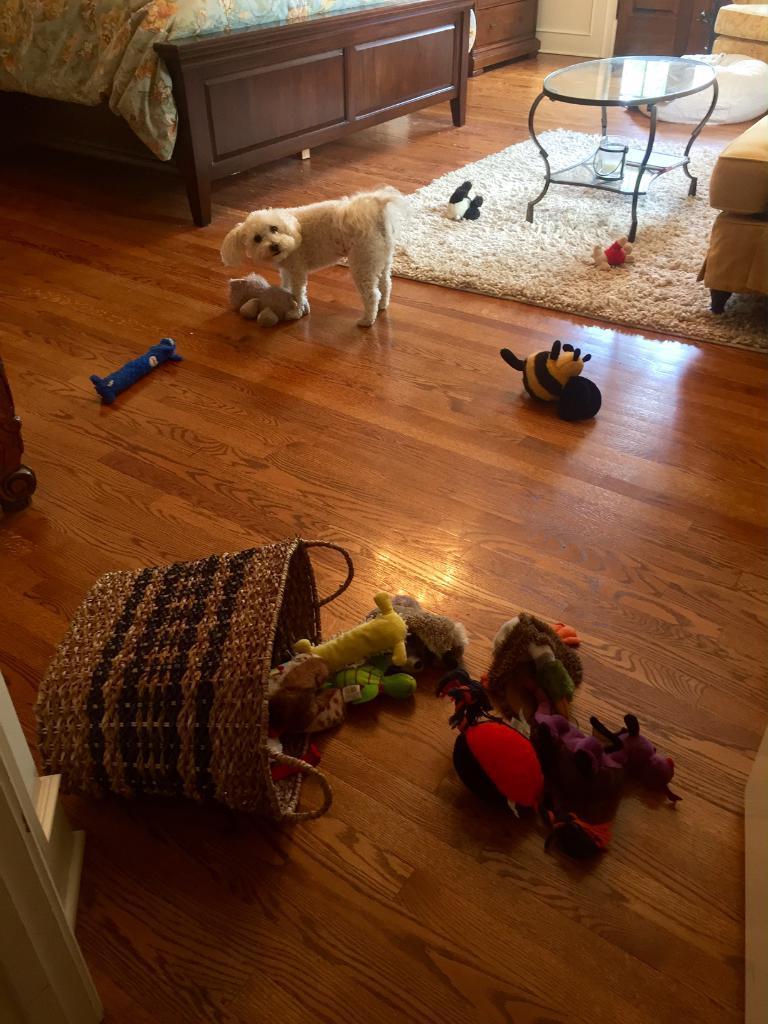Please provide a concise description of this image. In this image there is a bed truncated towards the top of the image, there is a blanket on the bed, there is a table, there is a puppy, there are couch truncated towards the right of the image, there are objects on the ground, there are objects truncated towards the left of the image, there are objects truncated towards the top of the image. 